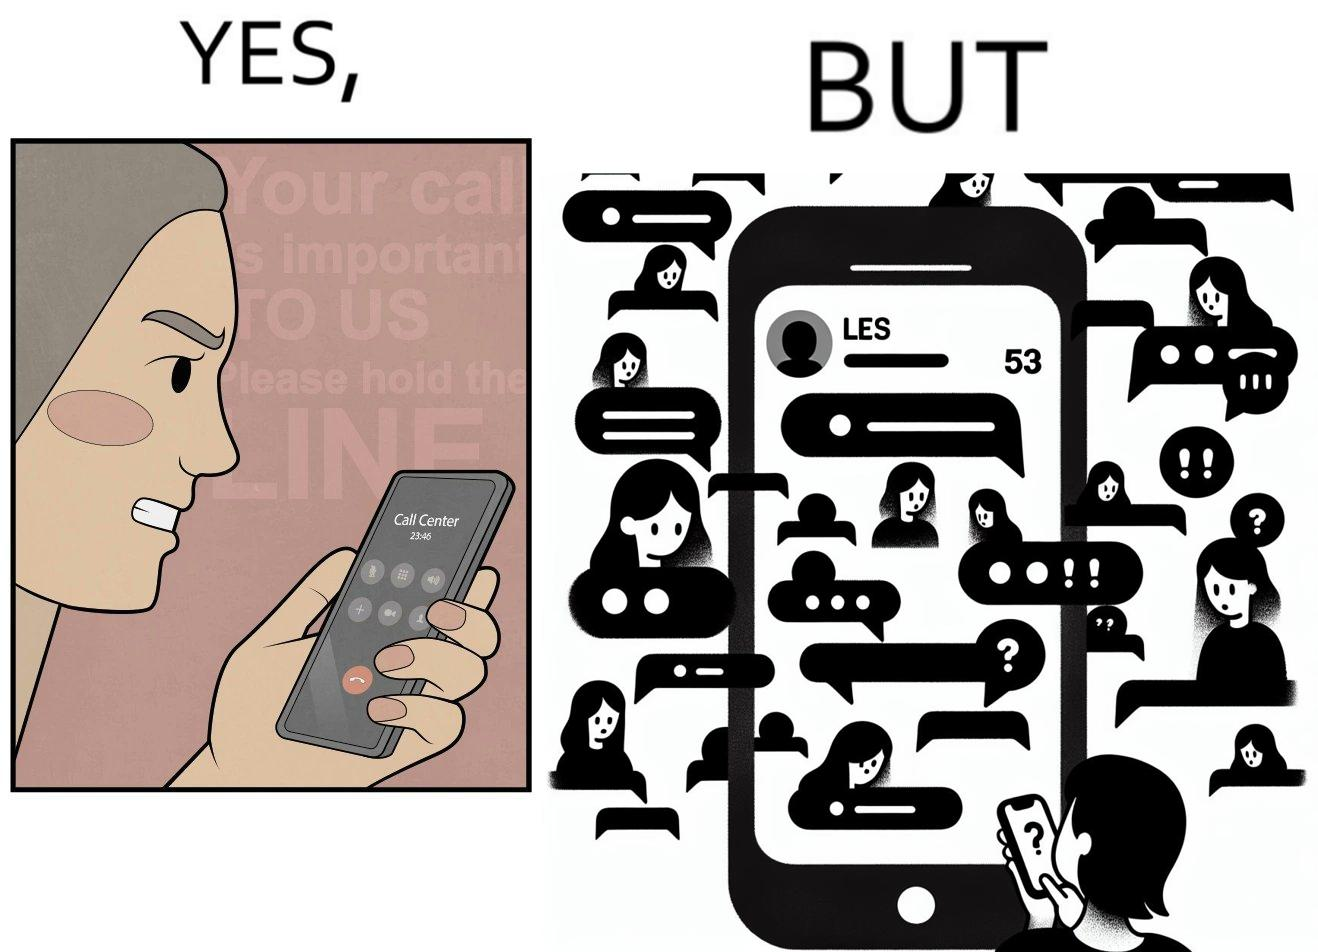Describe the content of this image. The image is ironical because while the woman is annoyed by the unresponsiveness of the call center, she herself is being unresponsive to many people in the chat. 